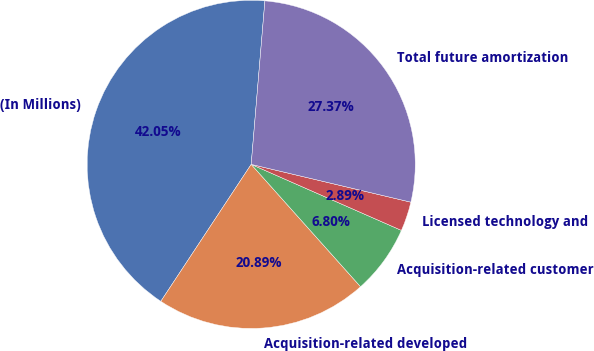<chart> <loc_0><loc_0><loc_500><loc_500><pie_chart><fcel>(In Millions)<fcel>Acquisition-related developed<fcel>Acquisition-related customer<fcel>Licensed technology and<fcel>Total future amortization<nl><fcel>42.05%<fcel>20.89%<fcel>6.8%<fcel>2.89%<fcel>27.37%<nl></chart> 